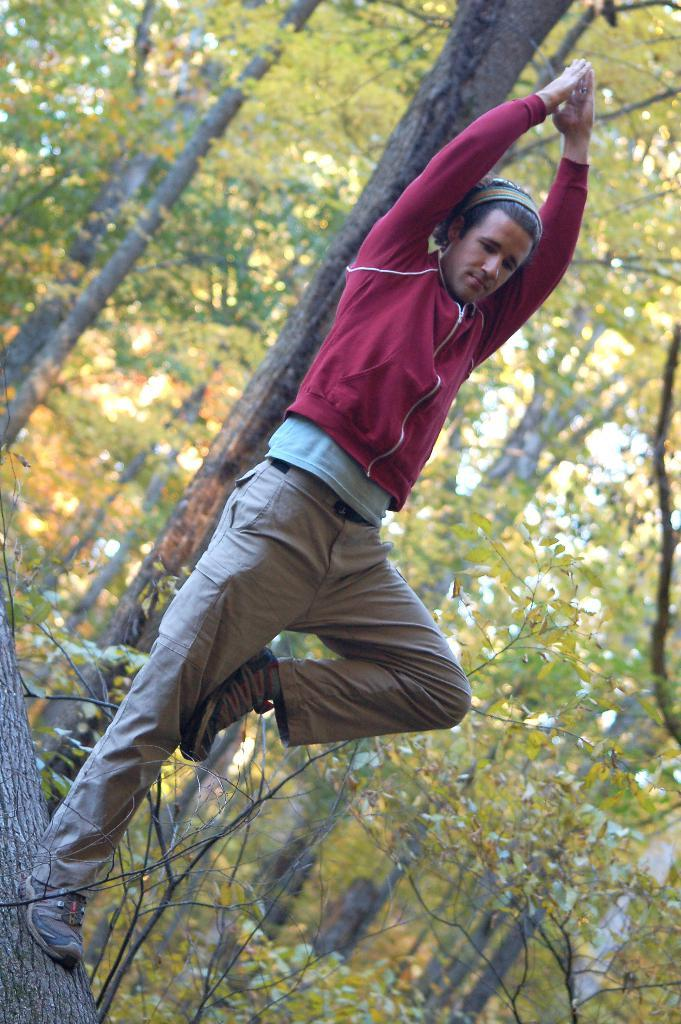Who is present in the image? There is a man in the image. What is the man doing in the image? The man is standing in the image. What is the man wearing in the image? The man is wearing a red jacket in the image. What can be seen in the background of the image? There are trees in the background of the image. How many balls can be seen in the image? There are no balls present in the image. 